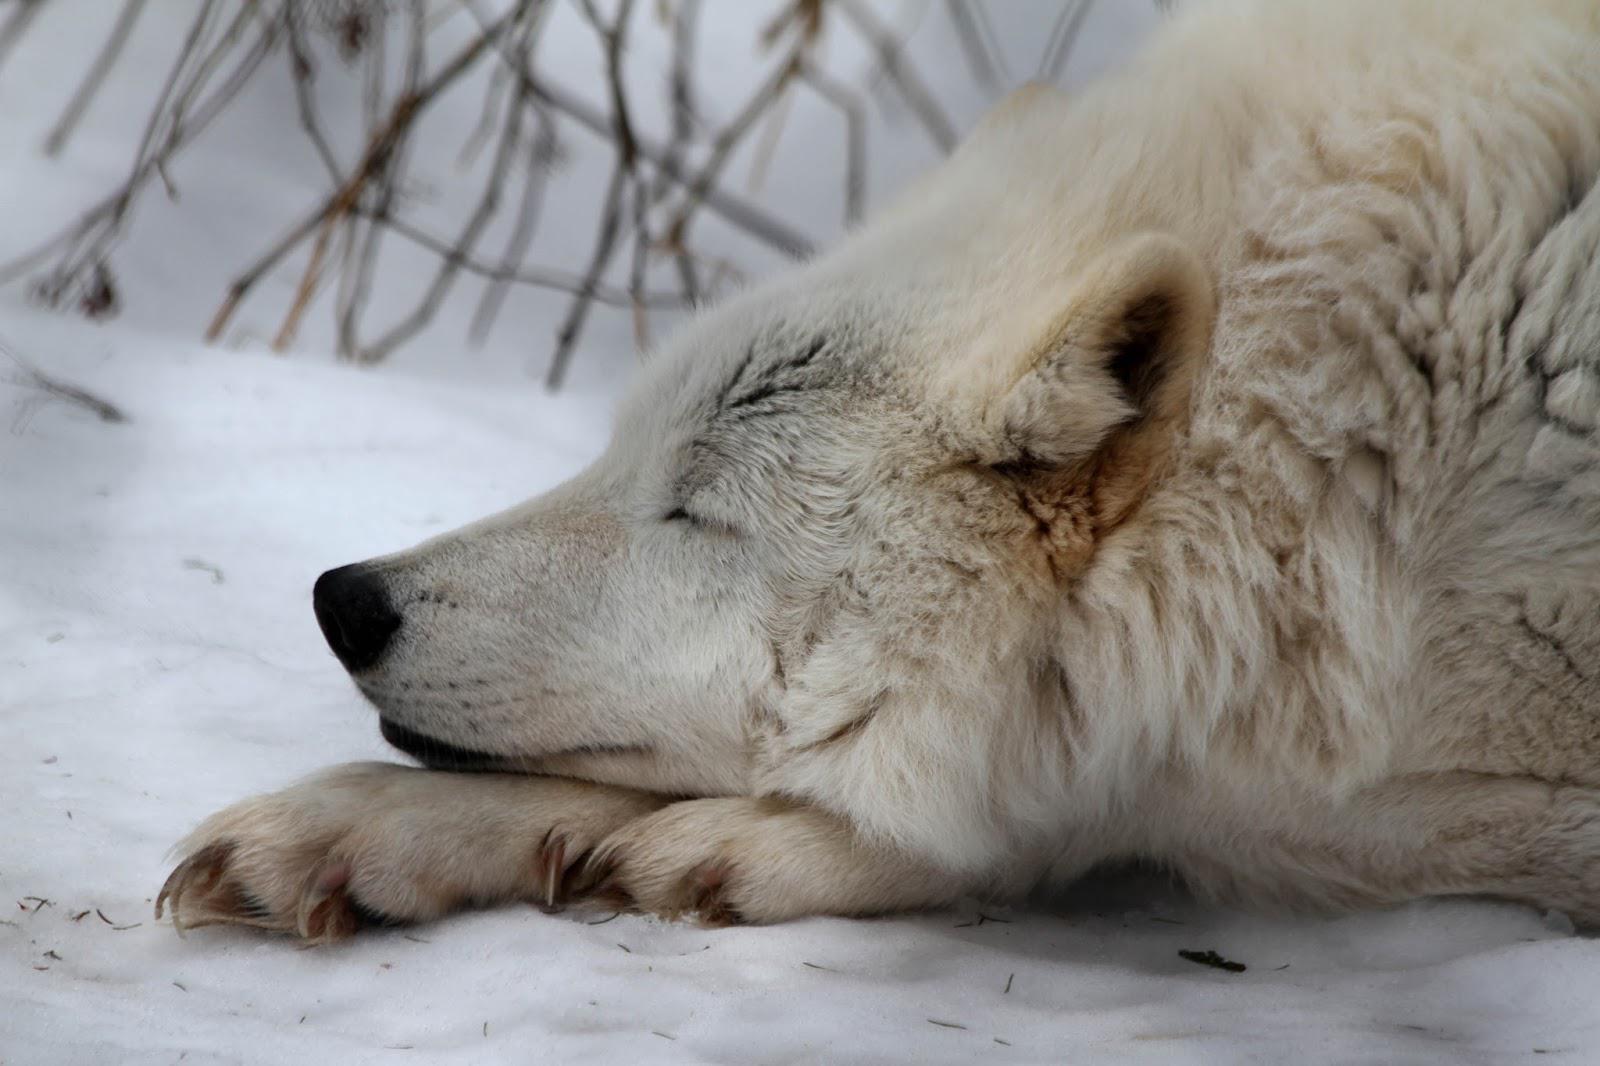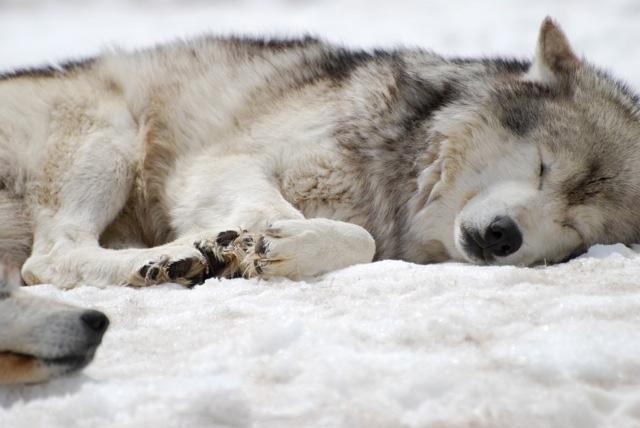The first image is the image on the left, the second image is the image on the right. Analyze the images presented: Is the assertion "One whitish wolf sleeps with its chin resting on its paws in one image." valid? Answer yes or no. Yes. The first image is the image on the left, the second image is the image on the right. Considering the images on both sides, is "At least one wolf is sleeping in the snow." valid? Answer yes or no. Yes. 